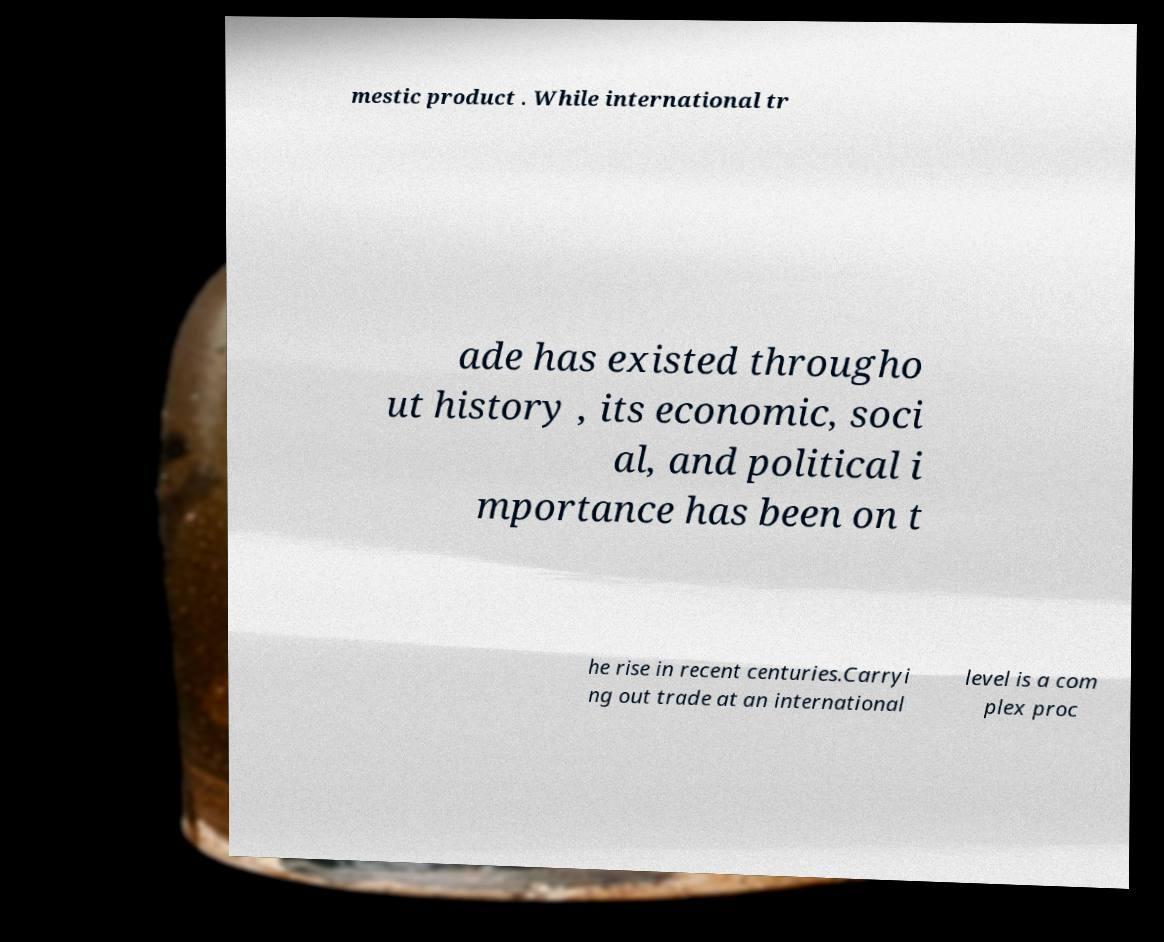I need the written content from this picture converted into text. Can you do that? mestic product . While international tr ade has existed througho ut history , its economic, soci al, and political i mportance has been on t he rise in recent centuries.Carryi ng out trade at an international level is a com plex proc 